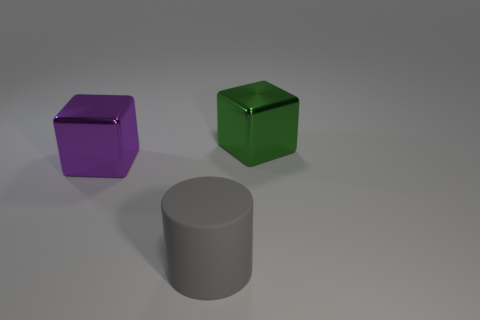What material is the cylinder that is the same size as the green metallic thing?
Offer a terse response. Rubber. Is there a green metal object of the same shape as the big purple shiny thing?
Offer a very short reply. Yes. What is the shape of the gray rubber thing that is the same size as the purple metallic cube?
Your answer should be compact. Cylinder. How big is the metal thing that is in front of the big green metal thing?
Give a very brief answer. Large. How many rubber things are the same size as the gray cylinder?
Your response must be concise. 0. What color is the other cube that is the same material as the large green cube?
Provide a succinct answer. Purple. Is the number of cubes that are to the left of the gray thing less than the number of large cubes?
Offer a terse response. Yes. What shape is the other thing that is made of the same material as the large green object?
Provide a succinct answer. Cube. What number of metallic objects are either objects or purple things?
Provide a succinct answer. 2. Are there an equal number of gray rubber cylinders that are behind the purple block and tiny red cylinders?
Make the answer very short. Yes. 